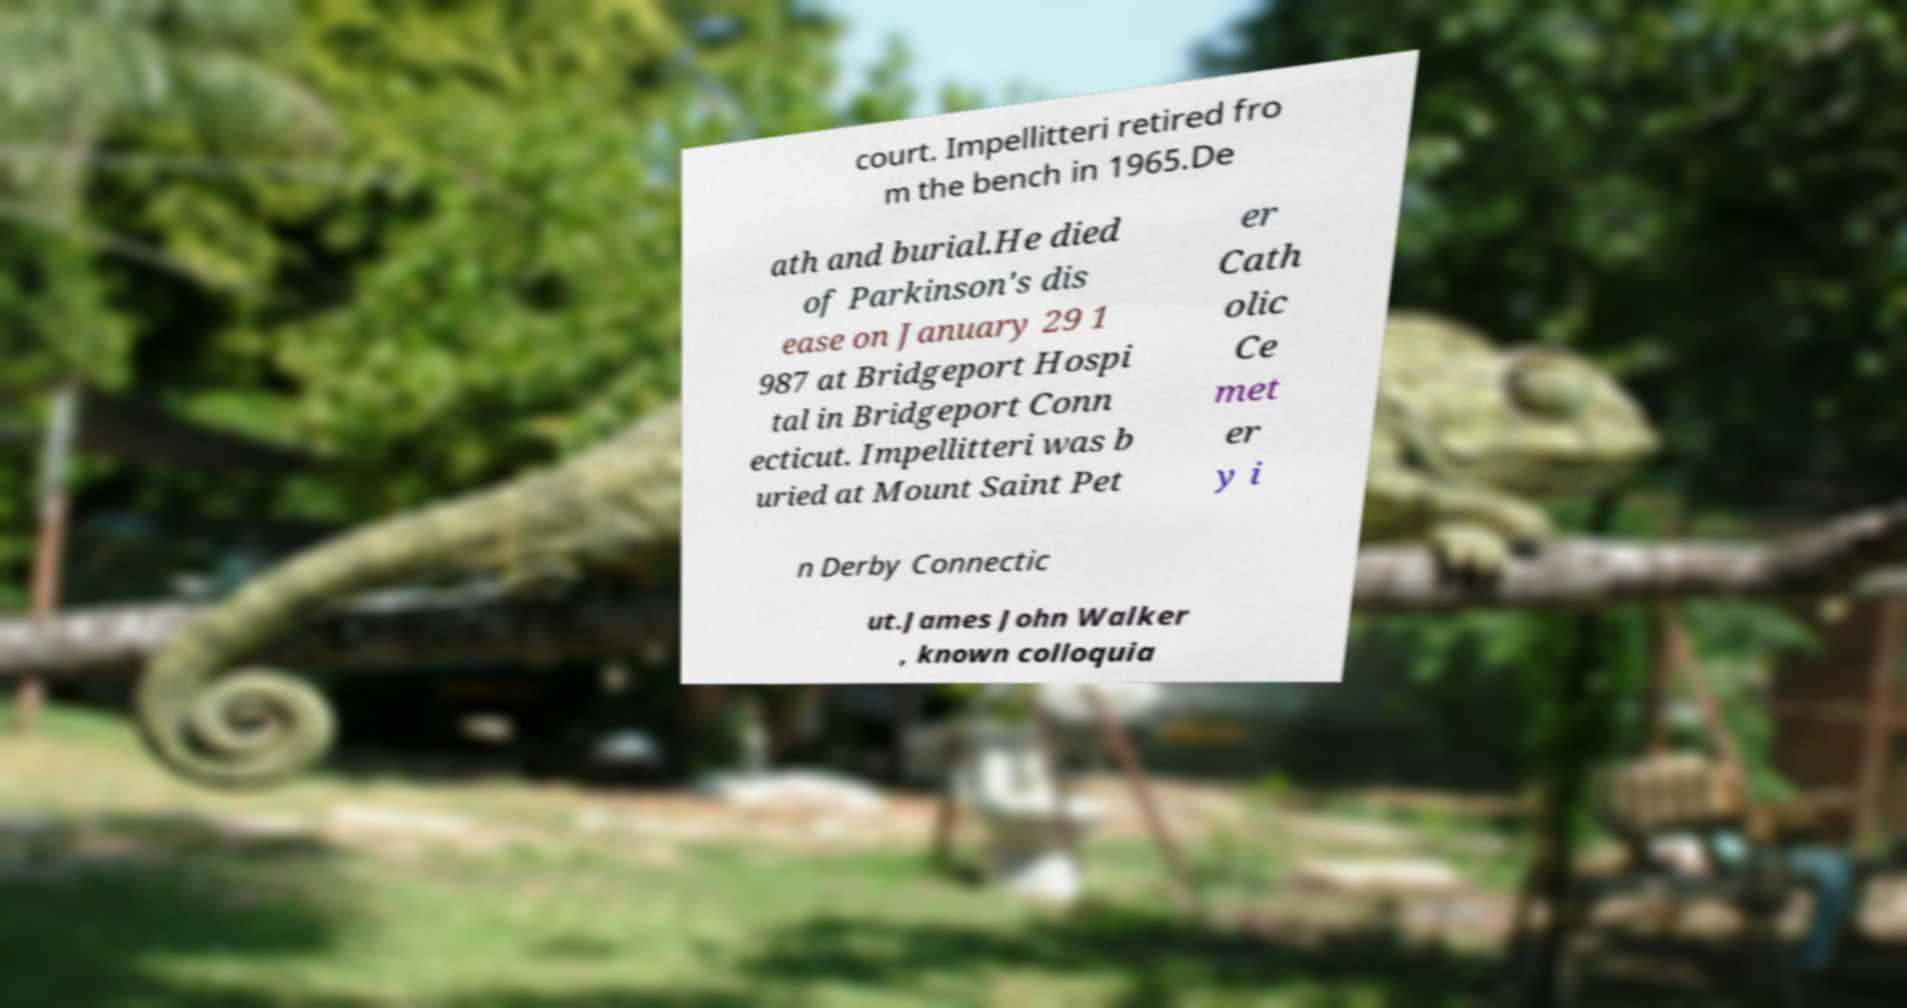Can you accurately transcribe the text from the provided image for me? court. Impellitteri retired fro m the bench in 1965.De ath and burial.He died of Parkinson's dis ease on January 29 1 987 at Bridgeport Hospi tal in Bridgeport Conn ecticut. Impellitteri was b uried at Mount Saint Pet er Cath olic Ce met er y i n Derby Connectic ut.James John Walker , known colloquia 